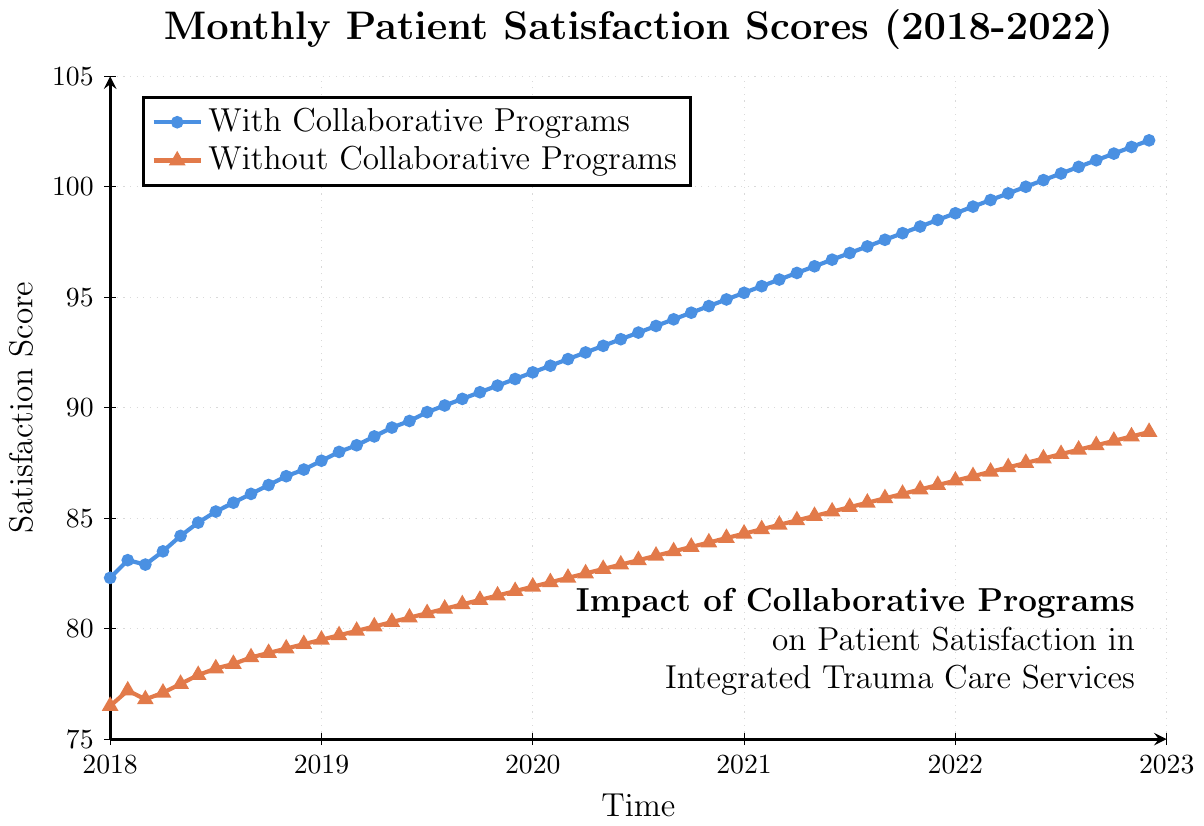Which year has the highest overall satisfaction score for hospitals with collaborative programs? Looking at the trends for each year, 2022 shows the highest satisfaction score for hospitals with collaborative programs, specifically reaching 102.1 in December 2022.
Answer: 2022 How much higher is the satisfaction score for hospitals with collaborative programs compared to those without in December 2020? The score for hospitals with collaborative programs is 94.9, and for those without is 84.1. The difference is 94.9 - 84.1.
Answer: 10.8 Which month shows the smallest difference in satisfaction scores between hospitals with and without collaborative programs in 2020? By examining each month in 2020, we find the smallest difference is in January, where the scores are 91.6 (with) and 81.9 (without). The difference is 91.6 - 81.9.
Answer: January Has the trend of satisfaction scores for hospitals with collaborative programs been consistently increasing over the 5-year period? Observing the trend line for hospitals with collaborative programs from 2018 to 2022, the satisfaction scores consistently increase each month.
Answer: Yes What is the average satisfaction score for hospitals without collaborative programs over the entire period? Adding the monthly scores for hospitals without collaborative programs (771.0) and dividing by the number of months (60), the average is approximately 771.0 / 60.
Answer: 85.15 During which year do hospitals without collaborative programs first surpass an 85 satisfaction score? In 2021, the score exceeds 85 for the first time in June with a score of 85.3.
Answer: 2021 What is the exact difference in satisfaction scores between the two types of hospitals in June 2018? In June 2018, the satisfaction scores are 84.8 (with) and 77.9 (without). The difference is 84.8 - 77.9.
Answer: 6.9 Which dataset shows lower variability in patient satisfaction scores over the 5 years? The trend lines show that hospitals without collaborative programs exhibit a more steady increase in scores, indicating lower variability compared to the steeper increase in scores for hospitals with collaborative programs.
Answer: Without Collaborative Programs Between which two consecutive months does the biggest increase in satisfaction scores for hospitals with collaborative programs occur? By examining the score differences month to month, the biggest increase is between December 2019 and January 2020, from 91.3 to 91.6, an increase of 0.3.
Answer: December 2019 - January 2020 